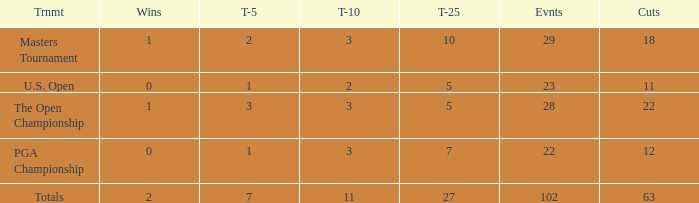How many top 10s associated with 3 top 5s and under 22 cuts made? None. 